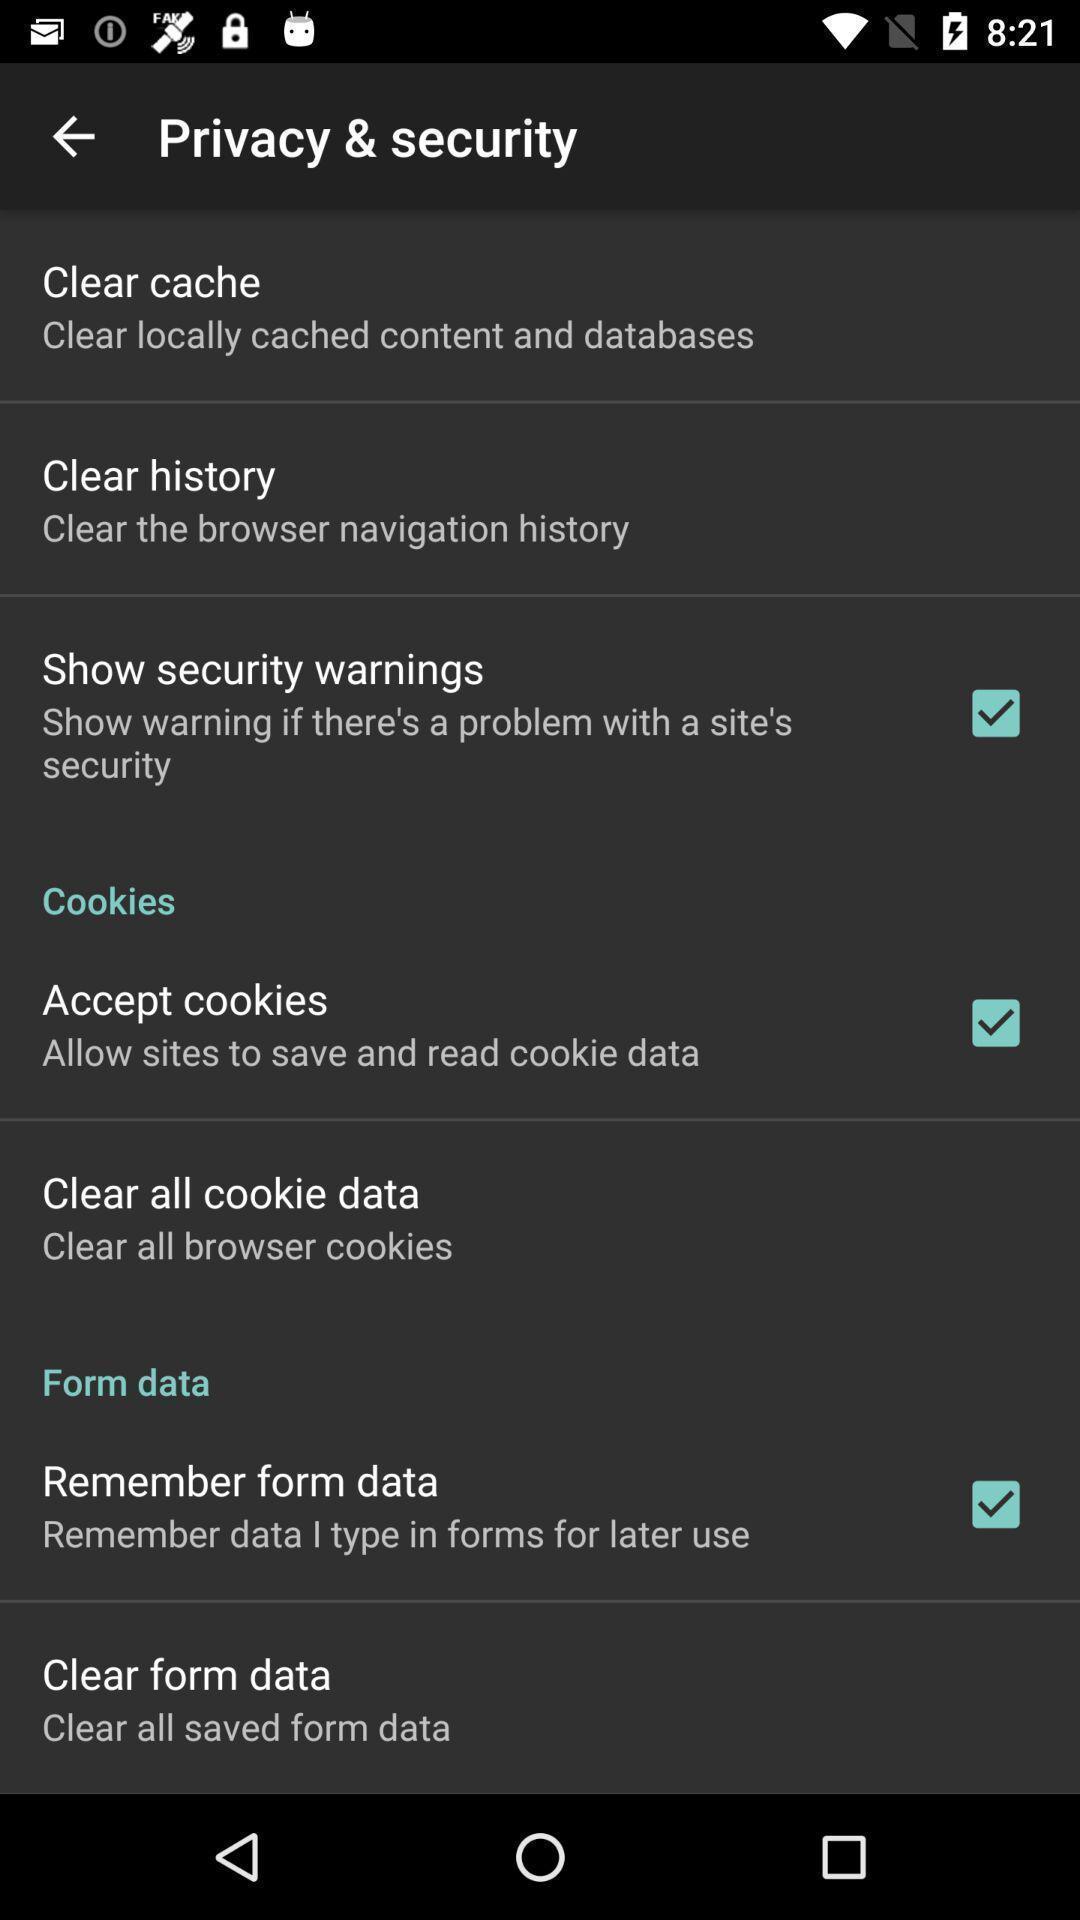Describe the key features of this screenshot. Screen shows general privacy settings. 